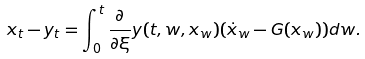<formula> <loc_0><loc_0><loc_500><loc_500>x _ { t } - y _ { t } = \int _ { 0 } ^ { t } { \frac { \partial } { \partial \xi } y ( t , w , x _ { w } ) ( \dot { x } _ { w } - G ( x _ { w } ) ) d w } .</formula> 